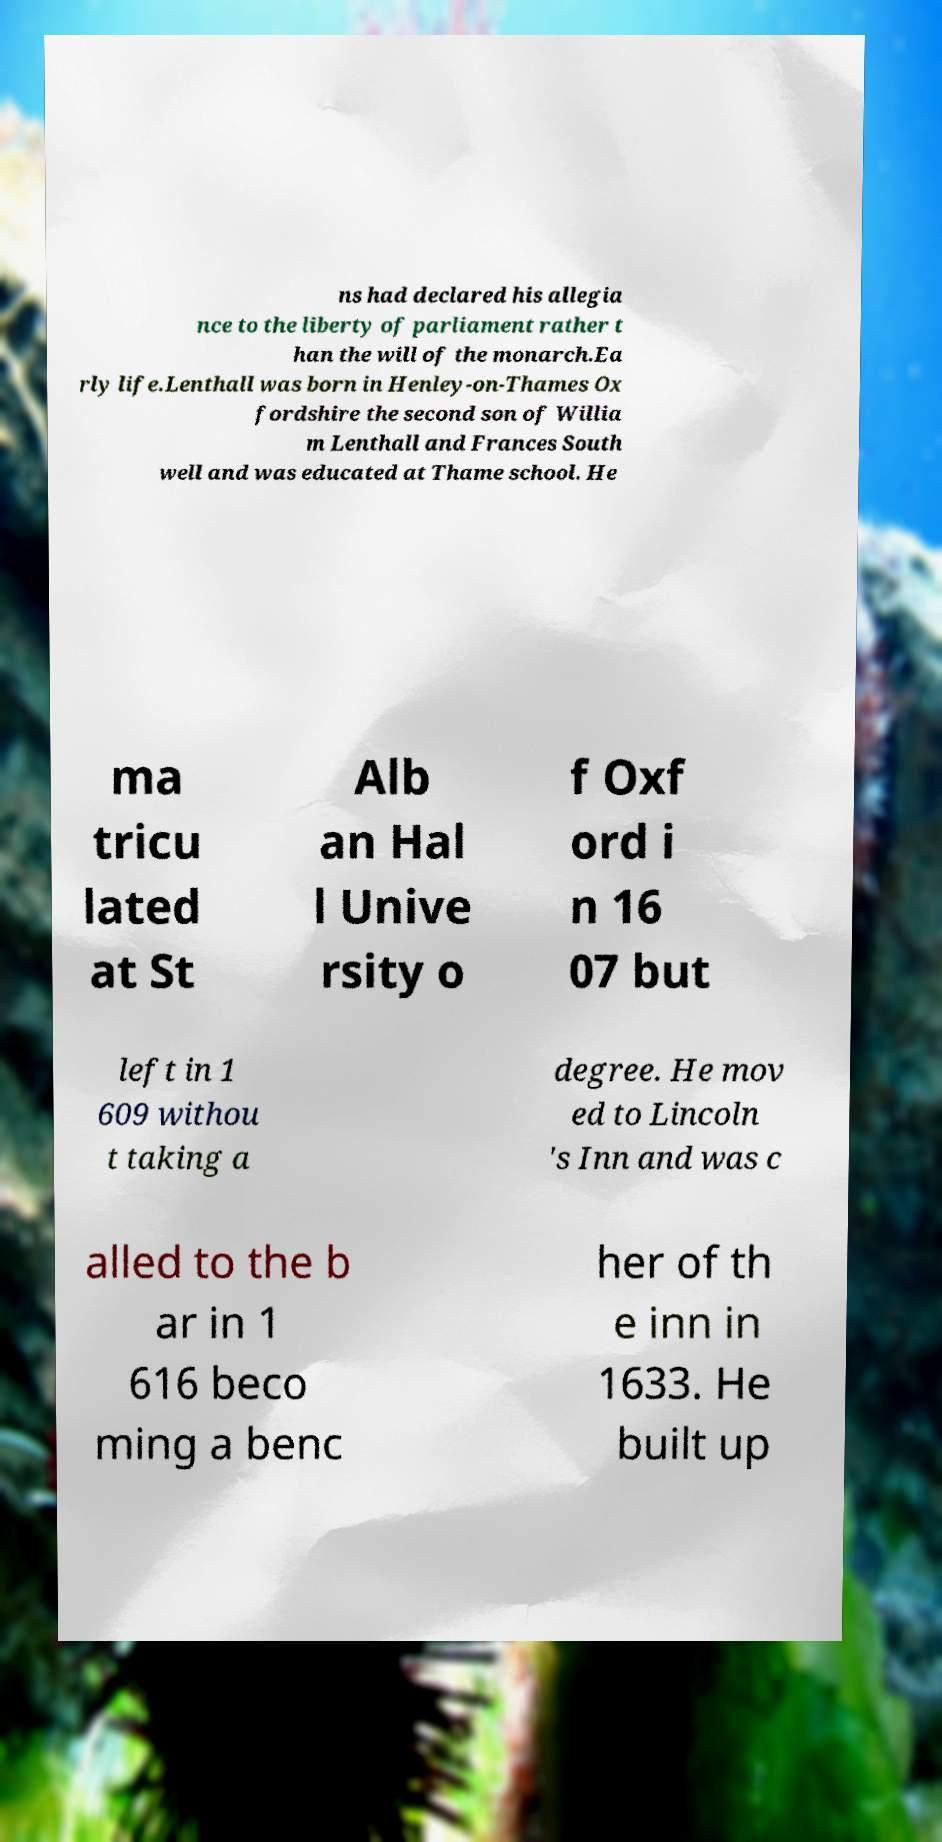Can you accurately transcribe the text from the provided image for me? ns had declared his allegia nce to the liberty of parliament rather t han the will of the monarch.Ea rly life.Lenthall was born in Henley-on-Thames Ox fordshire the second son of Willia m Lenthall and Frances South well and was educated at Thame school. He ma tricu lated at St Alb an Hal l Unive rsity o f Oxf ord i n 16 07 but left in 1 609 withou t taking a degree. He mov ed to Lincoln 's Inn and was c alled to the b ar in 1 616 beco ming a benc her of th e inn in 1633. He built up 